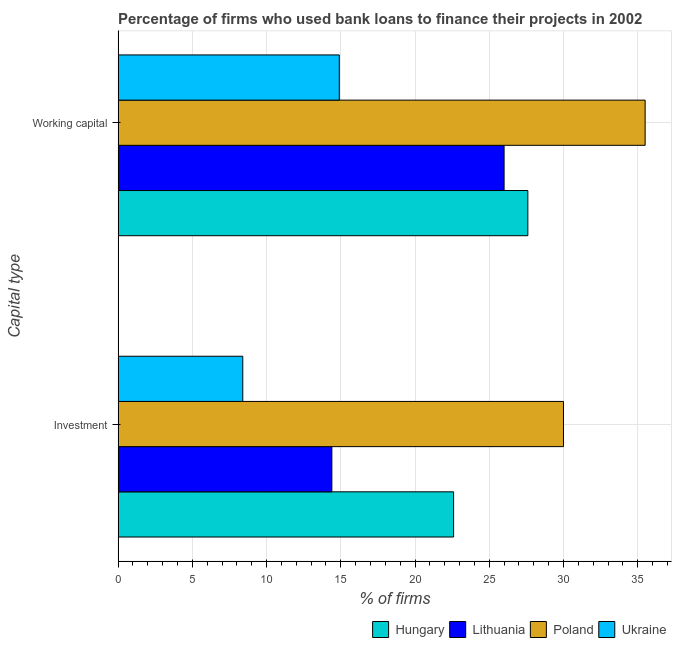How many different coloured bars are there?
Your response must be concise. 4. How many groups of bars are there?
Offer a terse response. 2. Are the number of bars per tick equal to the number of legend labels?
Ensure brevity in your answer.  Yes. How many bars are there on the 2nd tick from the top?
Give a very brief answer. 4. What is the label of the 2nd group of bars from the top?
Offer a terse response. Investment. What is the percentage of firms using banks to finance investment in Lithuania?
Give a very brief answer. 14.4. Across all countries, what is the maximum percentage of firms using banks to finance working capital?
Keep it short and to the point. 35.5. In which country was the percentage of firms using banks to finance investment minimum?
Your answer should be very brief. Ukraine. What is the total percentage of firms using banks to finance investment in the graph?
Your answer should be compact. 75.4. What is the average percentage of firms using banks to finance working capital per country?
Offer a very short reply. 26. In how many countries, is the percentage of firms using banks to finance working capital greater than 32 %?
Your response must be concise. 1. What is the ratio of the percentage of firms using banks to finance investment in Hungary to that in Ukraine?
Offer a very short reply. 2.69. What does the 3rd bar from the top in Working capital represents?
Your answer should be compact. Lithuania. What does the 1st bar from the bottom in Investment represents?
Make the answer very short. Hungary. How many bars are there?
Offer a terse response. 8. Are all the bars in the graph horizontal?
Your response must be concise. Yes. How many countries are there in the graph?
Give a very brief answer. 4. Does the graph contain grids?
Your answer should be compact. Yes. Where does the legend appear in the graph?
Provide a short and direct response. Bottom right. How many legend labels are there?
Provide a succinct answer. 4. How are the legend labels stacked?
Ensure brevity in your answer.  Horizontal. What is the title of the graph?
Your answer should be very brief. Percentage of firms who used bank loans to finance their projects in 2002. What is the label or title of the X-axis?
Your answer should be compact. % of firms. What is the label or title of the Y-axis?
Offer a terse response. Capital type. What is the % of firms in Hungary in Investment?
Your response must be concise. 22.6. What is the % of firms in Hungary in Working capital?
Provide a short and direct response. 27.6. What is the % of firms of Lithuania in Working capital?
Give a very brief answer. 26. What is the % of firms in Poland in Working capital?
Offer a very short reply. 35.5. Across all Capital type, what is the maximum % of firms of Hungary?
Your response must be concise. 27.6. Across all Capital type, what is the maximum % of firms of Poland?
Your answer should be very brief. 35.5. Across all Capital type, what is the minimum % of firms of Hungary?
Provide a succinct answer. 22.6. Across all Capital type, what is the minimum % of firms in Lithuania?
Your answer should be very brief. 14.4. Across all Capital type, what is the minimum % of firms in Poland?
Offer a terse response. 30. What is the total % of firms of Hungary in the graph?
Provide a short and direct response. 50.2. What is the total % of firms of Lithuania in the graph?
Your answer should be compact. 40.4. What is the total % of firms in Poland in the graph?
Your answer should be very brief. 65.5. What is the total % of firms of Ukraine in the graph?
Provide a succinct answer. 23.3. What is the difference between the % of firms of Hungary in Investment and that in Working capital?
Provide a short and direct response. -5. What is the difference between the % of firms of Ukraine in Investment and that in Working capital?
Your answer should be compact. -6.5. What is the difference between the % of firms of Hungary in Investment and the % of firms of Lithuania in Working capital?
Your answer should be compact. -3.4. What is the difference between the % of firms of Hungary in Investment and the % of firms of Poland in Working capital?
Offer a very short reply. -12.9. What is the difference between the % of firms in Lithuania in Investment and the % of firms in Poland in Working capital?
Ensure brevity in your answer.  -21.1. What is the difference between the % of firms in Poland in Investment and the % of firms in Ukraine in Working capital?
Provide a succinct answer. 15.1. What is the average % of firms in Hungary per Capital type?
Provide a short and direct response. 25.1. What is the average % of firms of Lithuania per Capital type?
Provide a short and direct response. 20.2. What is the average % of firms of Poland per Capital type?
Your answer should be very brief. 32.75. What is the average % of firms of Ukraine per Capital type?
Give a very brief answer. 11.65. What is the difference between the % of firms of Hungary and % of firms of Ukraine in Investment?
Make the answer very short. 14.2. What is the difference between the % of firms in Lithuania and % of firms in Poland in Investment?
Make the answer very short. -15.6. What is the difference between the % of firms of Lithuania and % of firms of Ukraine in Investment?
Your response must be concise. 6. What is the difference between the % of firms in Poland and % of firms in Ukraine in Investment?
Provide a short and direct response. 21.6. What is the difference between the % of firms in Hungary and % of firms in Lithuania in Working capital?
Ensure brevity in your answer.  1.6. What is the difference between the % of firms of Hungary and % of firms of Ukraine in Working capital?
Your answer should be very brief. 12.7. What is the difference between the % of firms in Lithuania and % of firms in Poland in Working capital?
Your response must be concise. -9.5. What is the difference between the % of firms of Lithuania and % of firms of Ukraine in Working capital?
Your answer should be compact. 11.1. What is the difference between the % of firms in Poland and % of firms in Ukraine in Working capital?
Give a very brief answer. 20.6. What is the ratio of the % of firms in Hungary in Investment to that in Working capital?
Your answer should be compact. 0.82. What is the ratio of the % of firms of Lithuania in Investment to that in Working capital?
Your response must be concise. 0.55. What is the ratio of the % of firms in Poland in Investment to that in Working capital?
Offer a terse response. 0.85. What is the ratio of the % of firms of Ukraine in Investment to that in Working capital?
Offer a terse response. 0.56. What is the difference between the highest and the second highest % of firms of Hungary?
Ensure brevity in your answer.  5. What is the difference between the highest and the second highest % of firms in Poland?
Your response must be concise. 5.5. What is the difference between the highest and the lowest % of firms in Hungary?
Offer a terse response. 5. What is the difference between the highest and the lowest % of firms of Ukraine?
Ensure brevity in your answer.  6.5. 